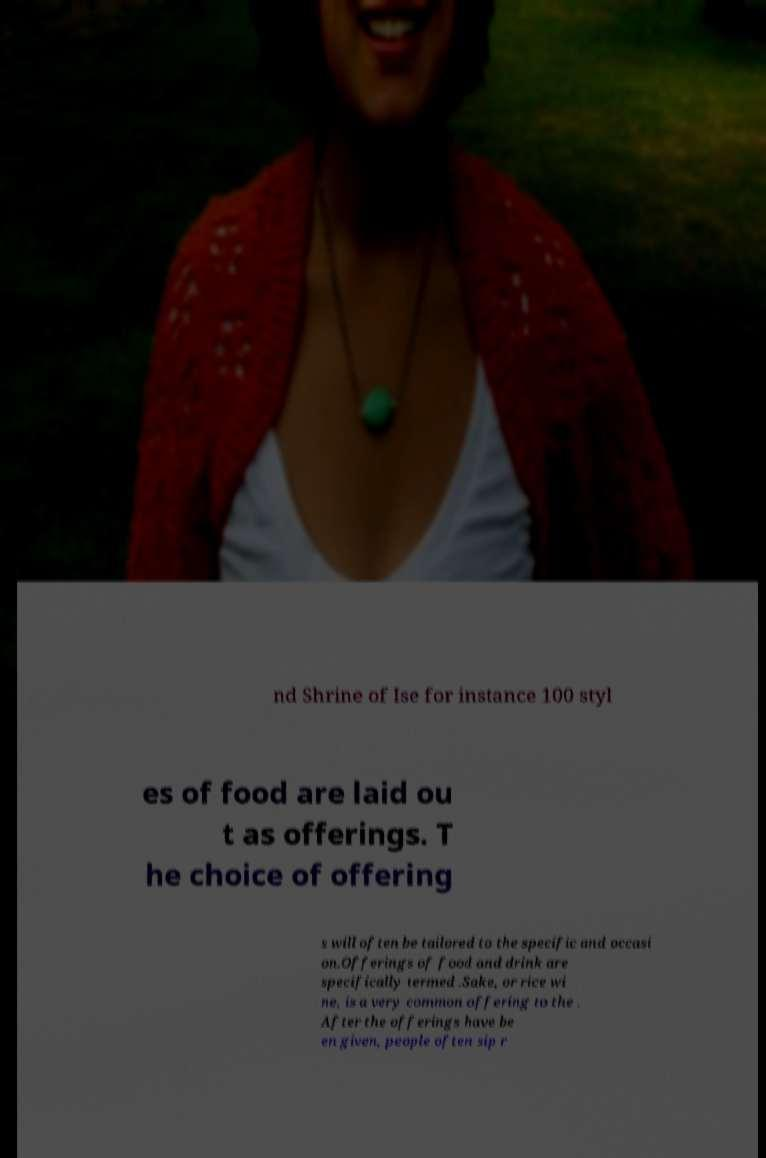For documentation purposes, I need the text within this image transcribed. Could you provide that? nd Shrine of Ise for instance 100 styl es of food are laid ou t as offerings. T he choice of offering s will often be tailored to the specific and occasi on.Offerings of food and drink are specifically termed .Sake, or rice wi ne, is a very common offering to the . After the offerings have be en given, people often sip r 